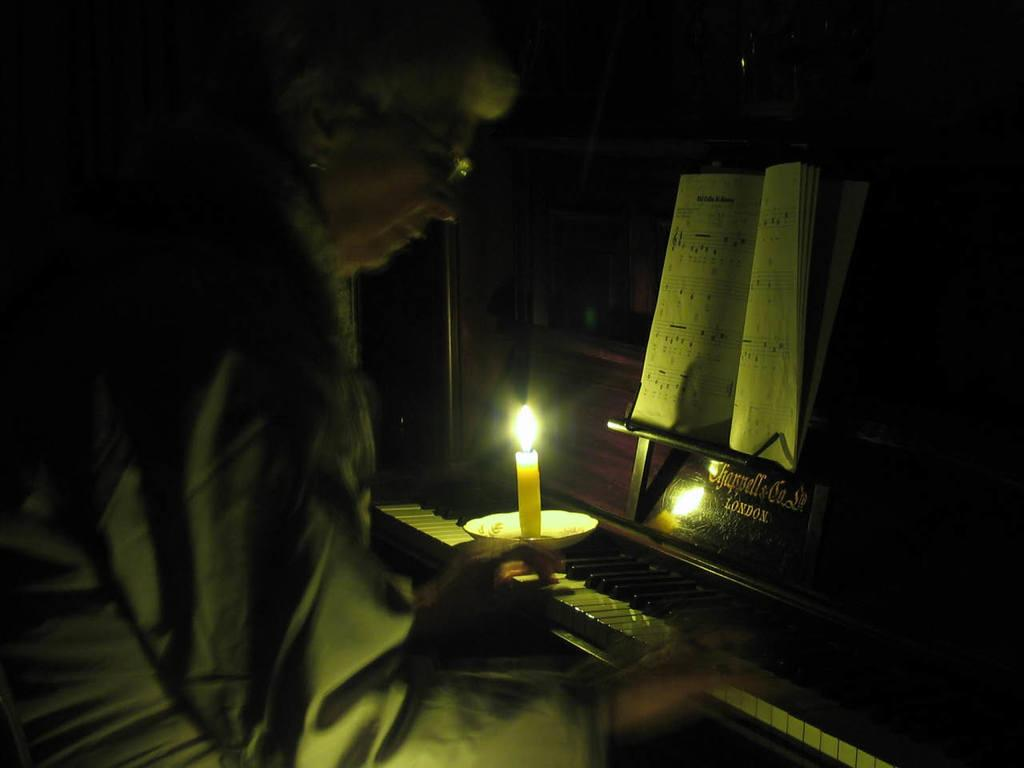What is the person in the image doing? The person is playing the guitar. Can you describe the person's appearance? The person is wearing glasses. What other objects can be seen in the image? There is a candle with a flame, a plate, a book, and a name board in the image. What type of advertisement is displayed on the plate in the image? There is no advertisement present on the plate in the image; it is a plate with an unspecified purpose. 